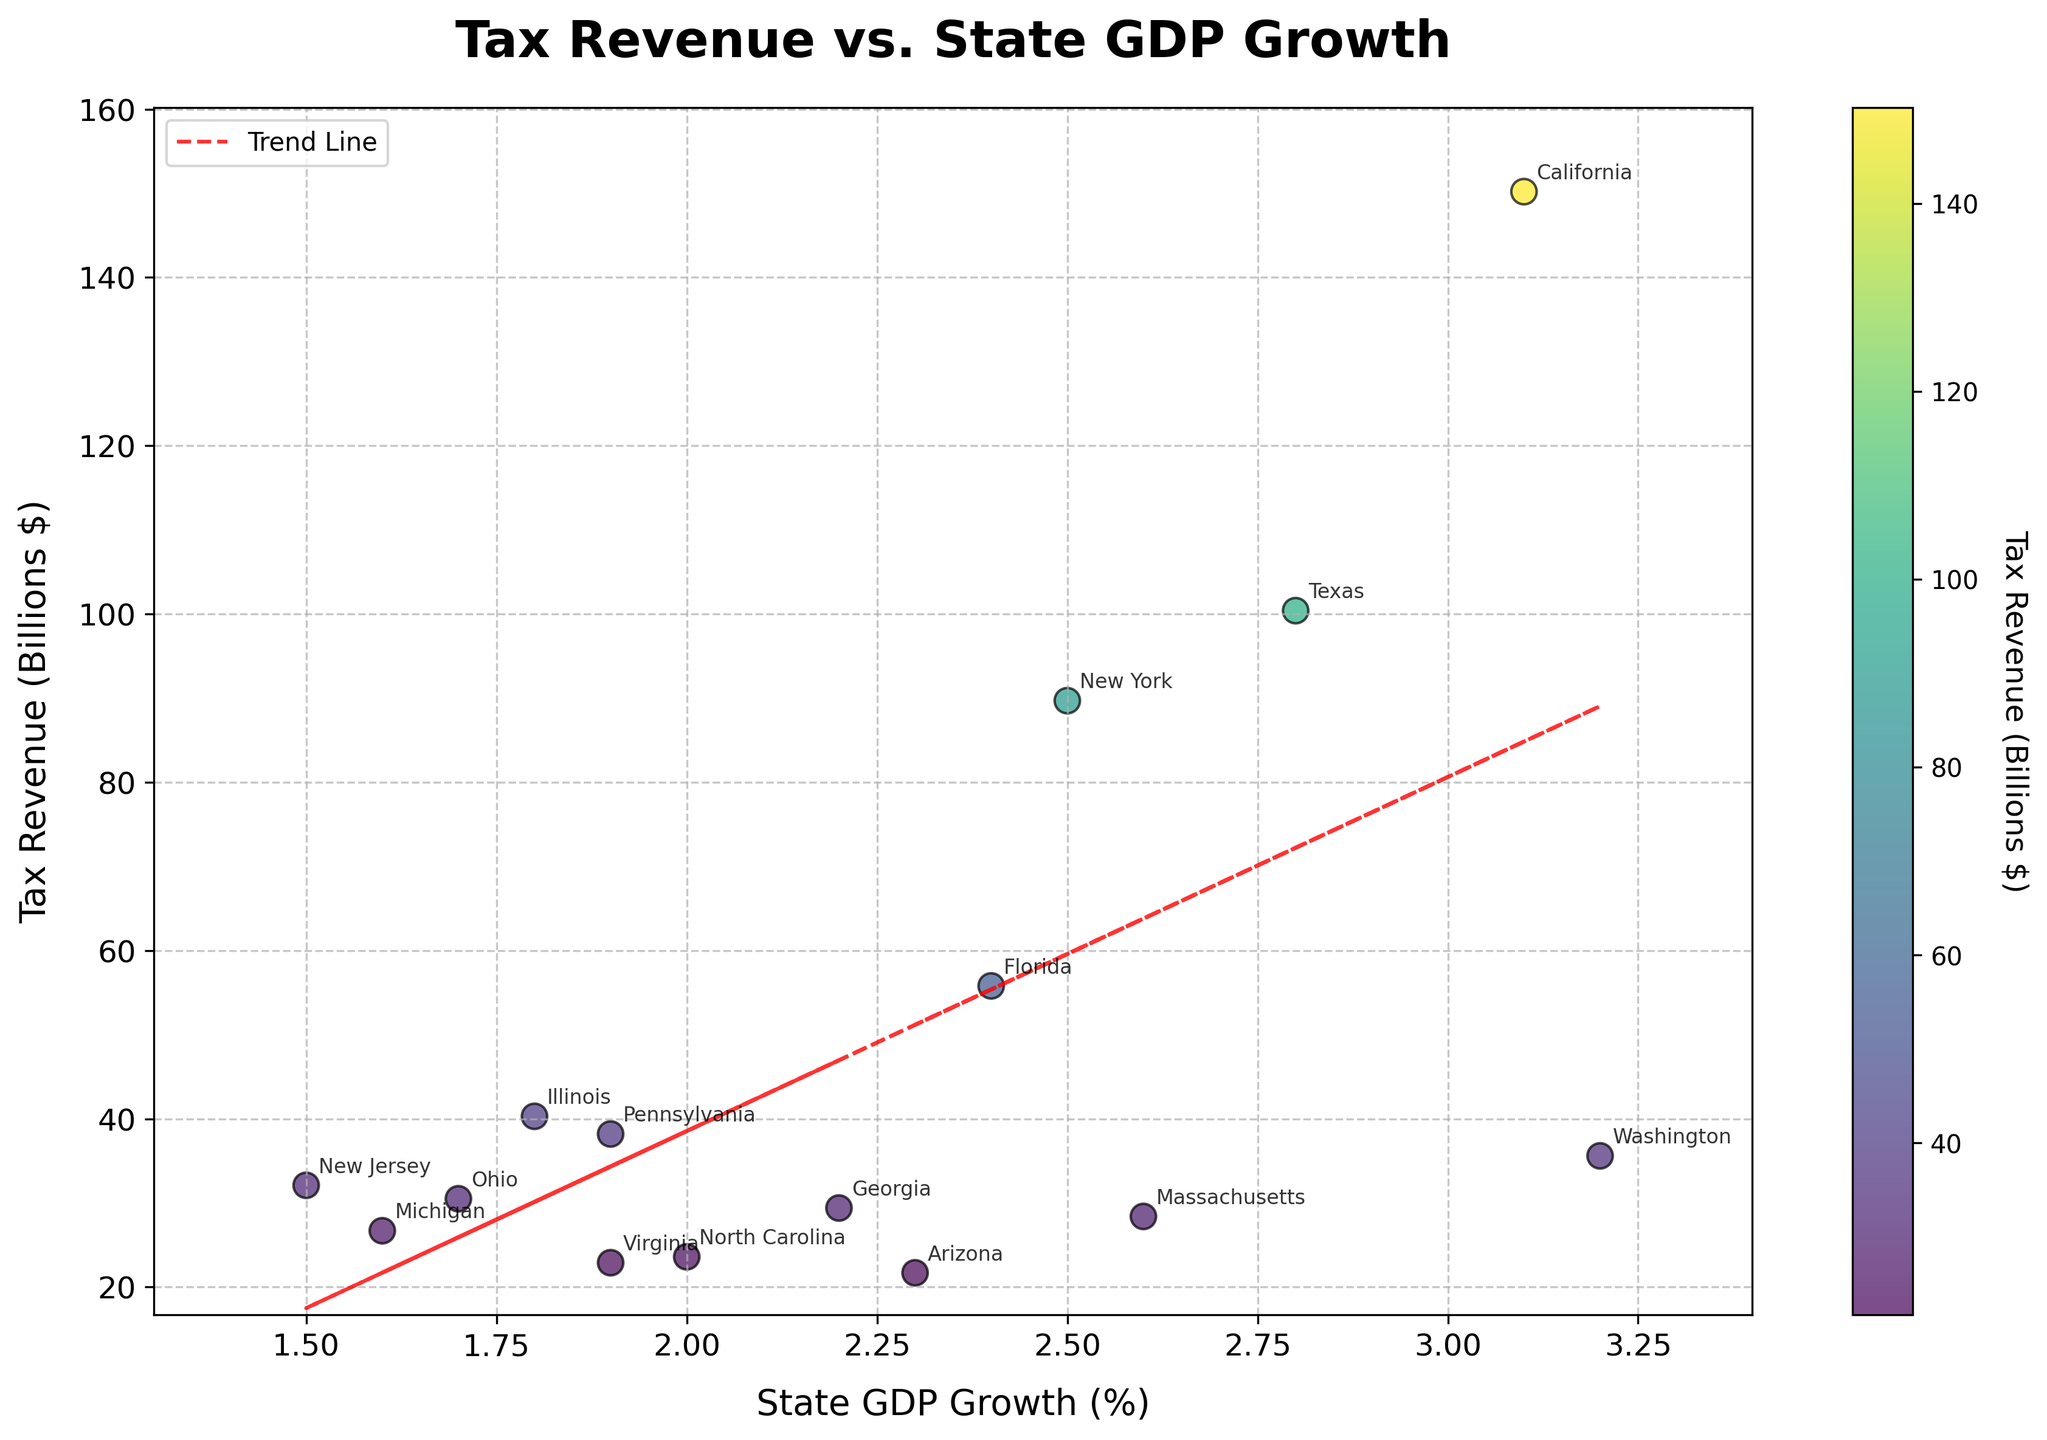What is the title of the scatter plot? The figure title is displayed at the top of the plot and reads 'Tax Revenue vs. State GDP Growth', which clearly indicates the relationship being presented.
Answer: Tax Revenue vs. State GDP Growth Which state has the highest tax revenue? By looking at the data points and the annotations, we see California positioned highest in terms of tax revenue on the y-axis.
Answer: California What is the GDP growth rate of the state with the lowest tax revenue? The state with the lowest tax revenue is Arizona, located at 21.7 billion dollars. The corresponding GDP growth rate is found along the x-axis and matches with 2.3%.
Answer: 2.3% Which two states have almost the same tax revenue but different GDP growth rates? By observing closely, New York and Washington have near-identical tax revenue values around 89.7 and 35.6 billion dollars, respectively, but different GDP growth rates of 2.5% and 3.2%.
Answer: New York and Washington What is the trend line equation? The trend line equation is derived from the scatter plot's red dotted line, generally displayed on the figure. It's a linear fit equation in the form: y = mx + b, but needs to be checked in the figure code.
Answer: Linear equation (Refer to figure) How many states have a GDP growth rate equal to or greater than 2.5%? States with GDP growth rates marked at or above 2.5% include (California, Texas, New York, Washington, Massachusetts, Florida, and Arizona) - totaling to seven states.
Answer: 7 Compare the tax revenue of Texas and New York. Which state has higher revenue and by how much? Observing the y-axis, Texas has a higher tax revenue (100.4 billion) compared to New York (89.7 billion), providing a difference of 100.4 - 89.7 = 10.7.
Answer: Texas by 10.7 billion What states are clustered around a GDP growth rate of 2.0%? States like North Carolina (2.0%), Pennsylvania (1.9%), and Virginia (1.9%) cluster around the same GDP growth rate of approximately 2.0%.
Answer: North Carolina, Pennsylvania, Virginia Based on the scatter plot, does a higher GDP growth rate always correspond to a higher tax revenue? Although there is a general trend, exceptions exist, e.g., New York has a higher tax revenue at a lower GDP growth rate compared to Washington. Thus, the trend is not absolute.
Answer: No 